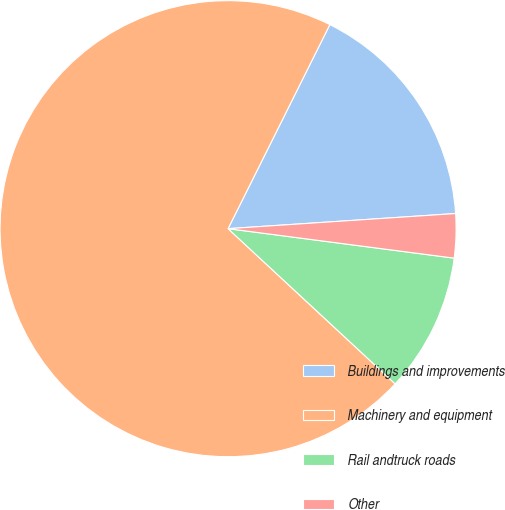Convert chart. <chart><loc_0><loc_0><loc_500><loc_500><pie_chart><fcel>Buildings and improvements<fcel>Machinery and equipment<fcel>Rail andtruck roads<fcel>Other<nl><fcel>16.58%<fcel>70.45%<fcel>9.85%<fcel>3.12%<nl></chart> 